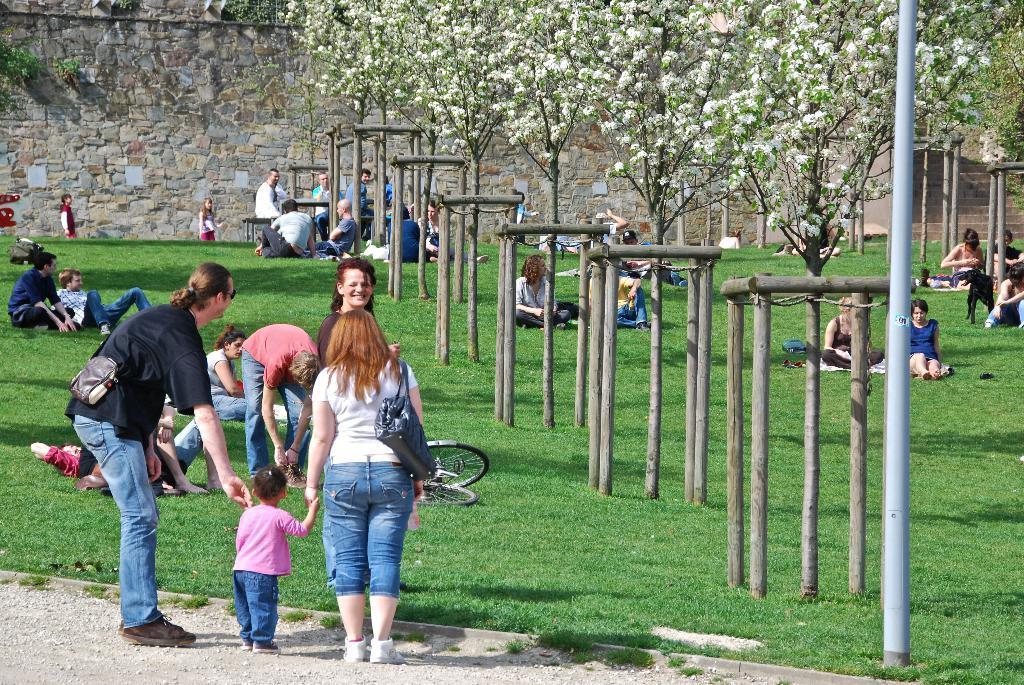Describe this image in one or two sentences. This picture describes about group of people, few are seated on the grass and few are standing, in the background we can see few trees, flowers, pole and a bicycle. 